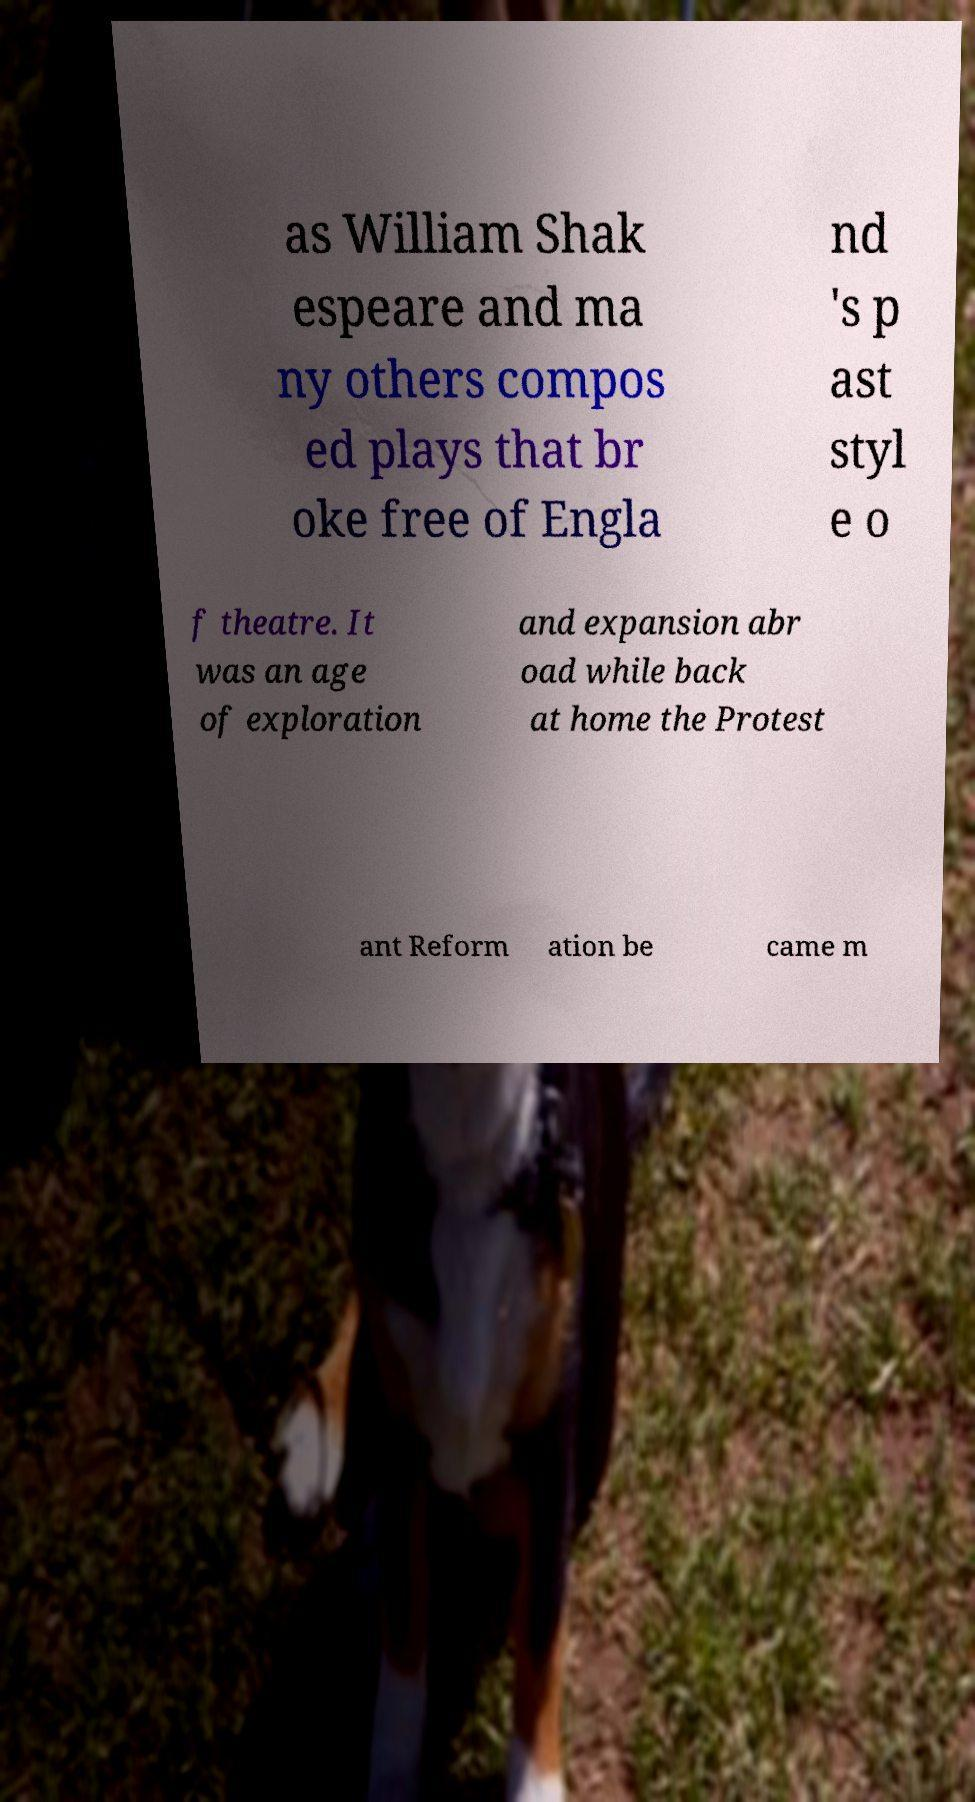Could you extract and type out the text from this image? as William Shak espeare and ma ny others compos ed plays that br oke free of Engla nd 's p ast styl e o f theatre. It was an age of exploration and expansion abr oad while back at home the Protest ant Reform ation be came m 